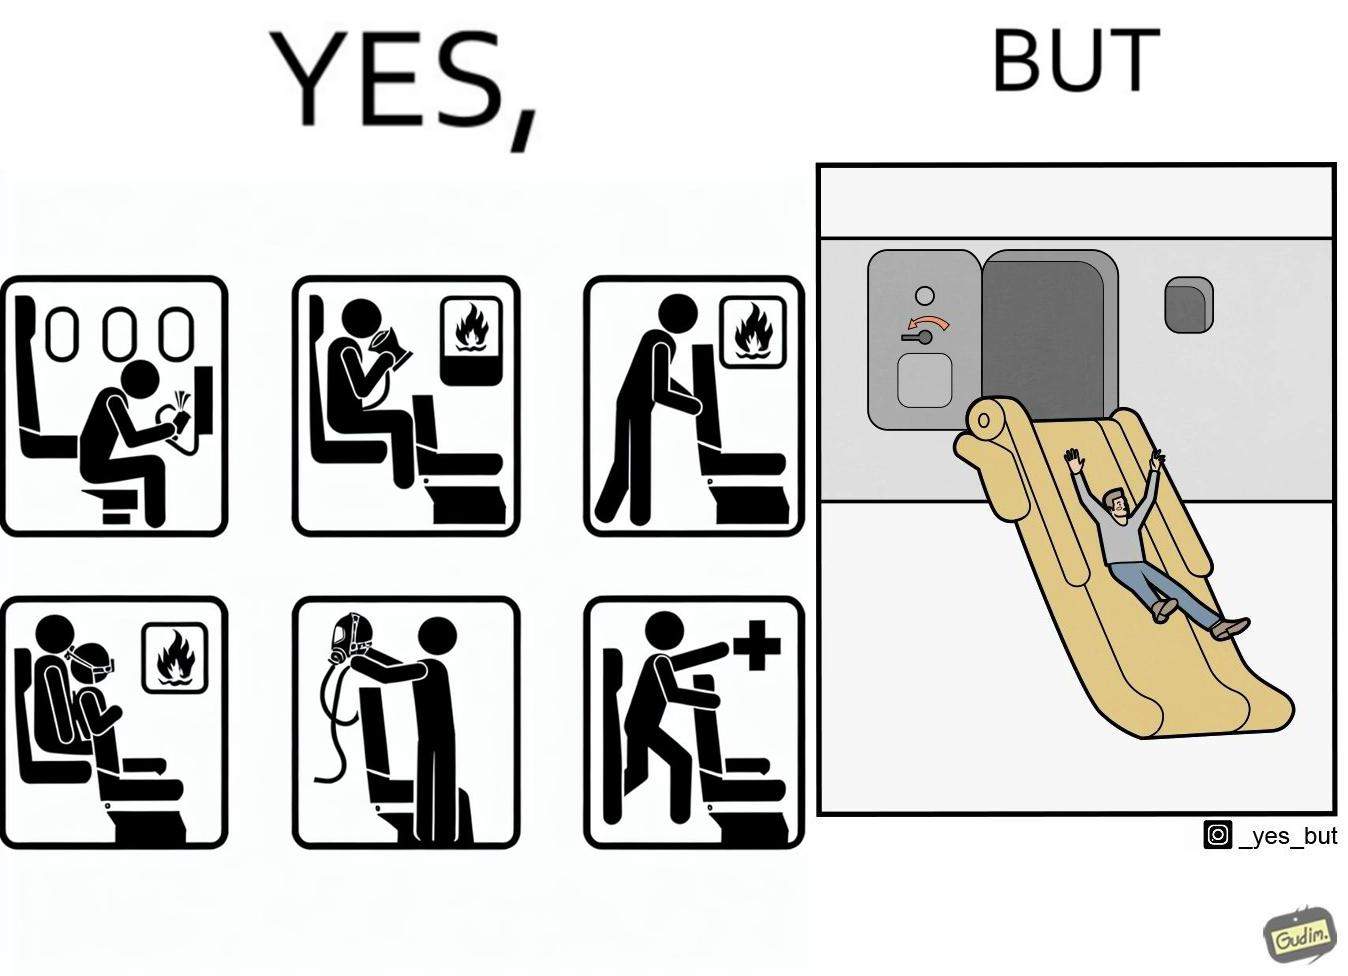Describe what you see in this image. These images are funny since it shows how we are taught emergency procedures to follow in case of an accident while in an airplane but how none of them work if the plane is still in air 